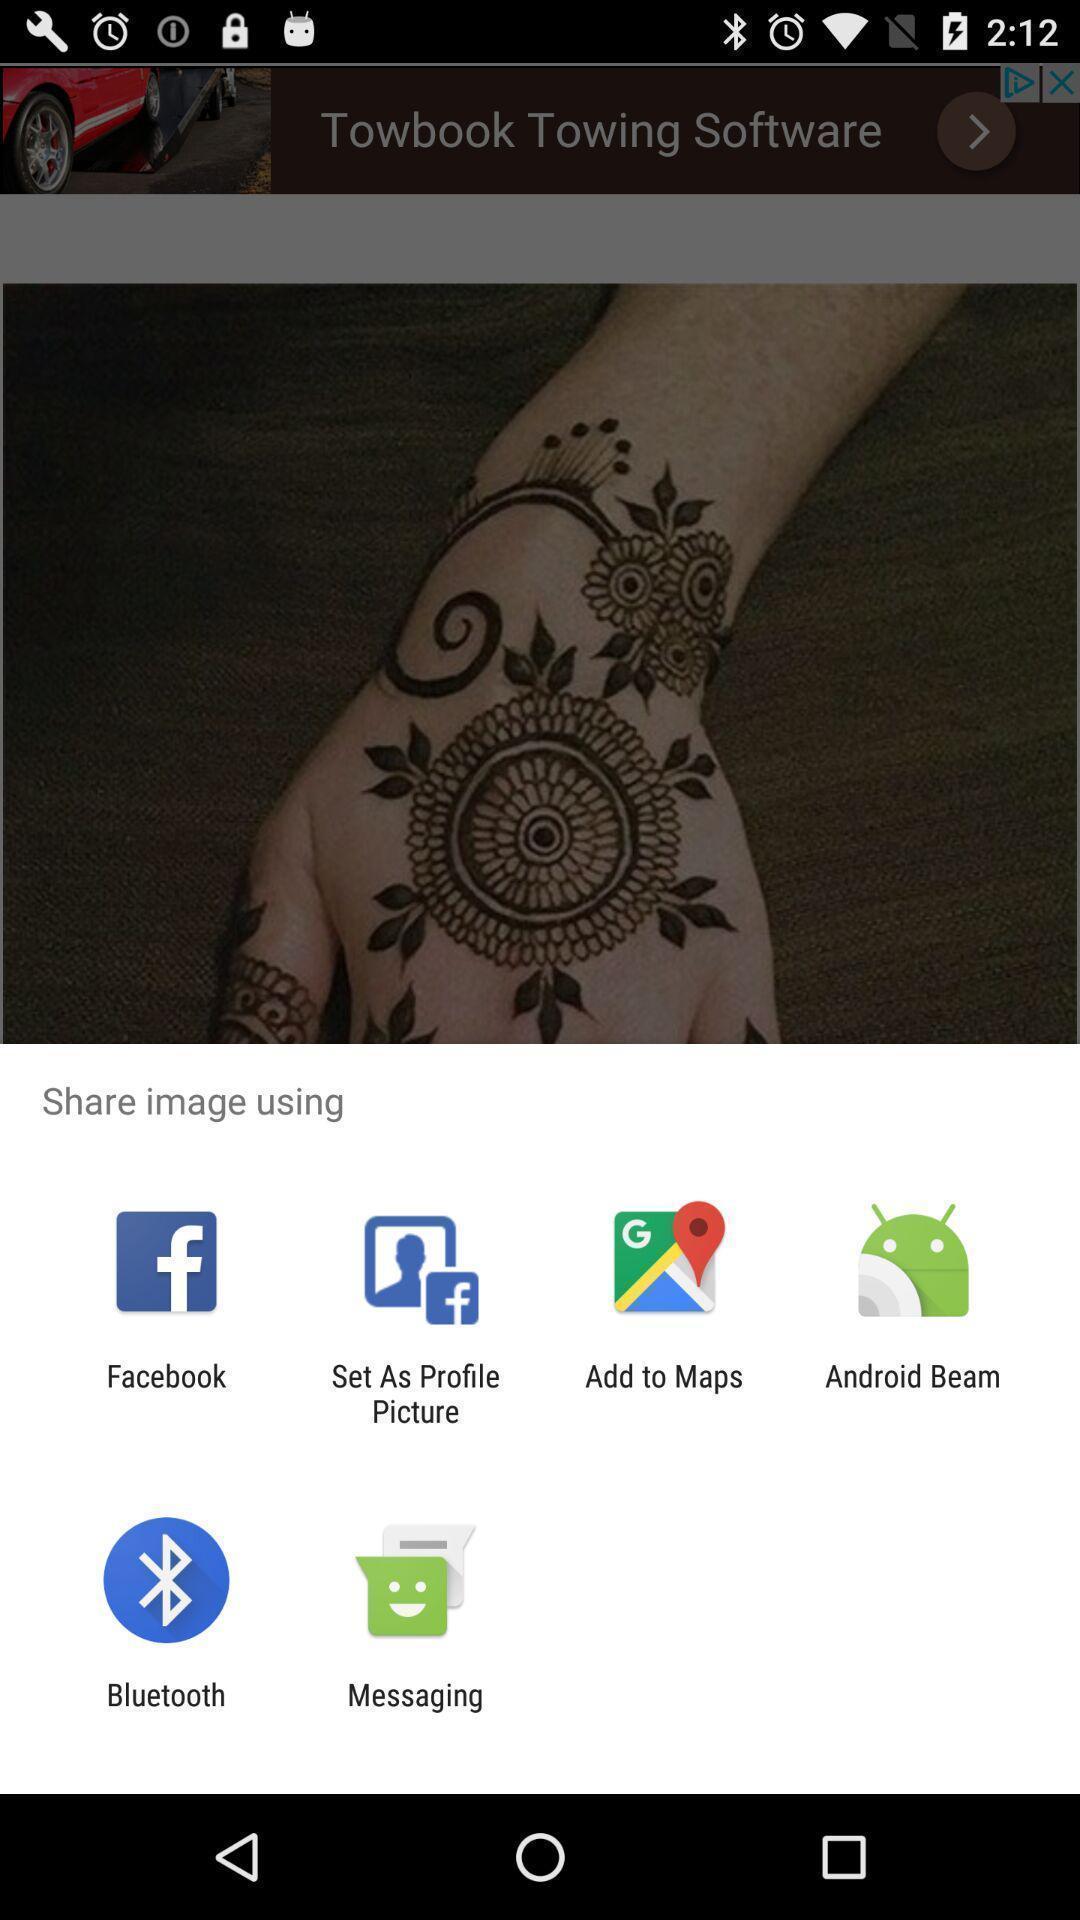Provide a description of this screenshot. Push up page showing app preference to share. 